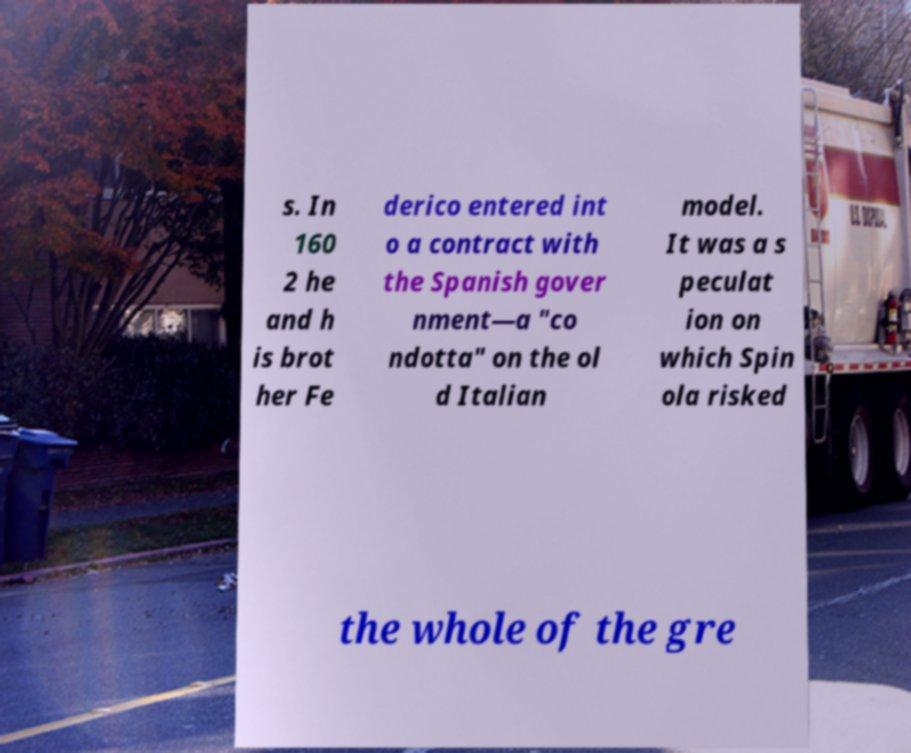Could you extract and type out the text from this image? s. In 160 2 he and h is brot her Fe derico entered int o a contract with the Spanish gover nment—a "co ndotta" on the ol d Italian model. It was a s peculat ion on which Spin ola risked the whole of the gre 